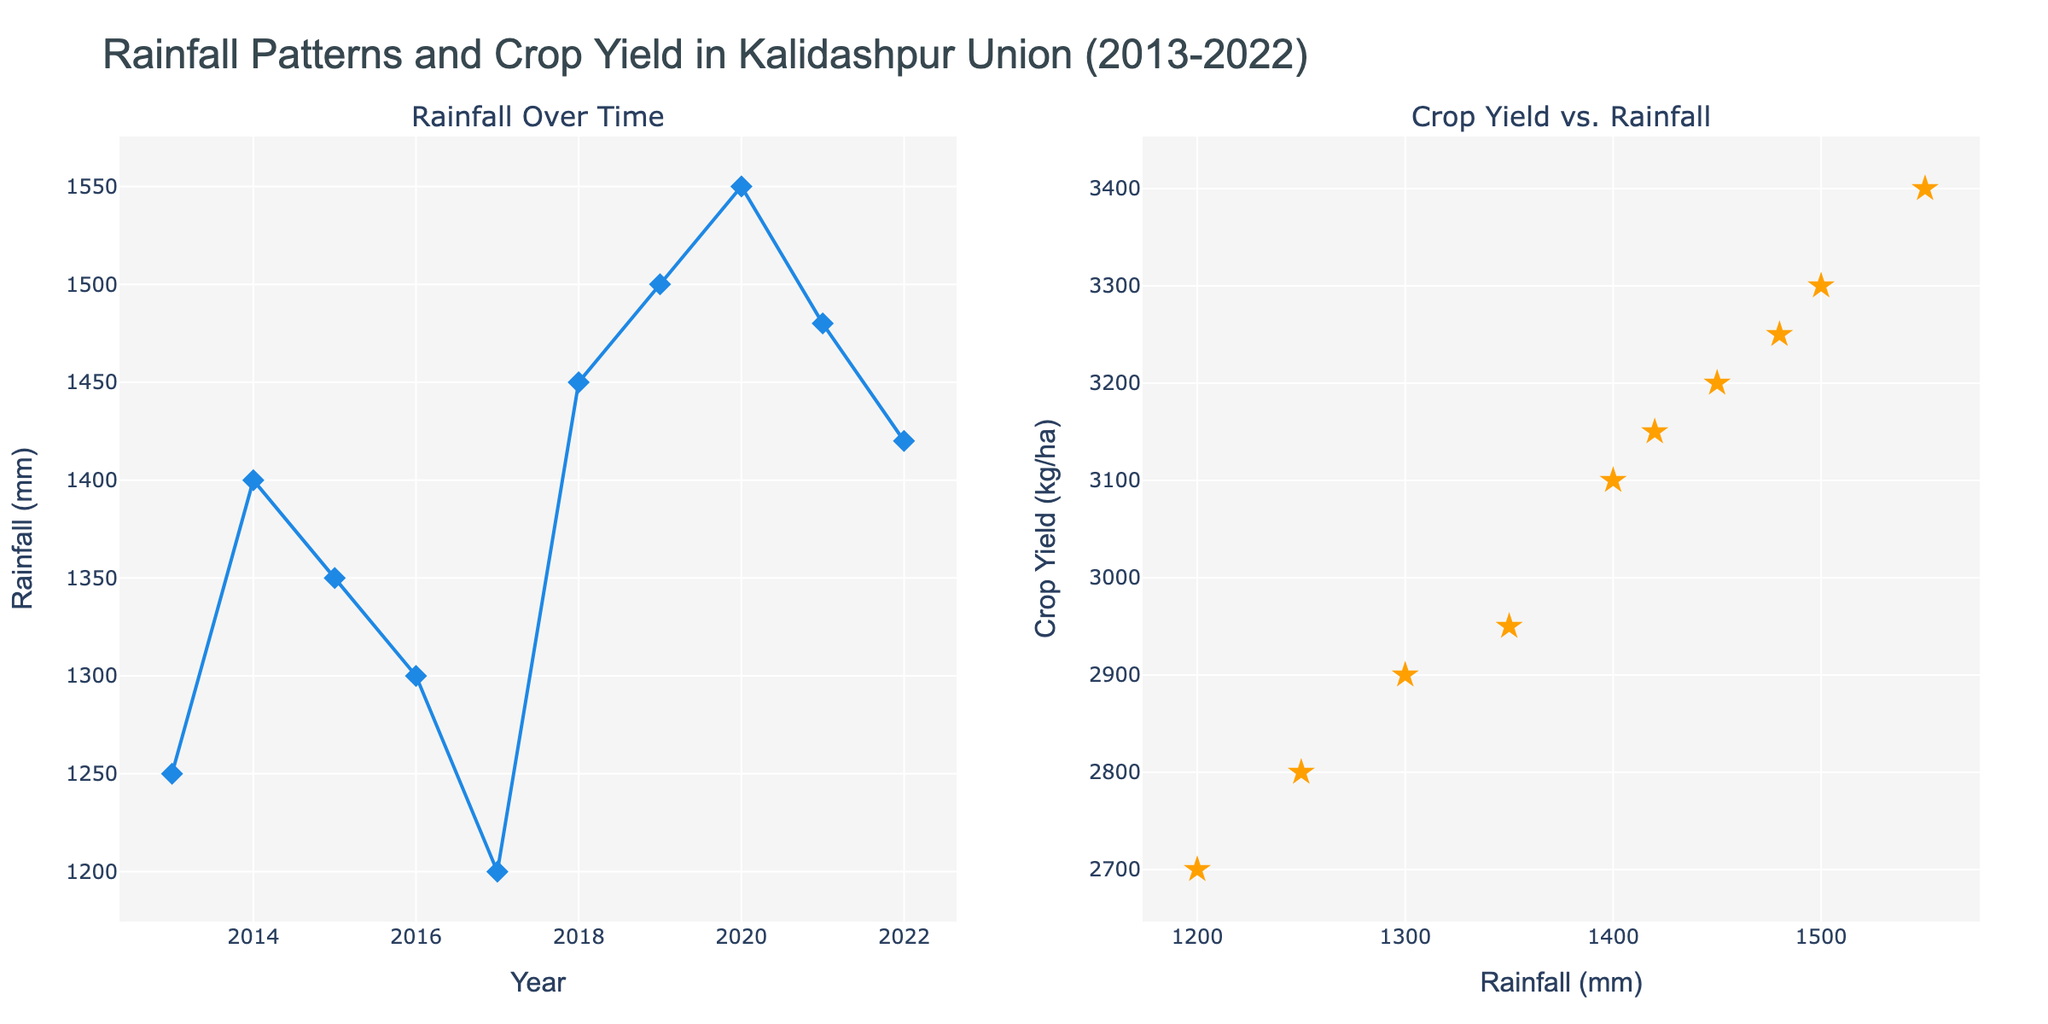What is the title of the figure? The title of the figure is displayed at the top, and it is the main heading for the plots.
Answer: Rainfall Patterns and Crop Yield in Kalidashpur Union (2013-2022) What is the color of the markers representing the crop yield in the scatter plot? The color of the markers for crop yield is indicated in the scatter plot on the right side of the figure.
Answer: Orange How many data points are there in each scatter plot? Both scatter plots represent yearly data from 2013 to 2022. There should be one data point for each year.
Answer: 10 Which year had the highest rainfall, and what was the crop yield that year? The year with the highest rainfall can be identified in the left plot where it peaks, and the corresponding crop yield is found in the right plot.
Answer: 2020, 3400 kg/ha What is the general trend between rainfall and crop yield over the given years? Examine the right scatter plot to observe how increases or decreases in rainfall are generally related to changes in crop yield.
Answer: Positive correlation Which year had the lowest crop yield, and what was the rainfall in that year? Identify the lowest point on the crop yield axis in the right scatter plot and check the corresponding rainfall value on the same plot.
Answer: 2017, 1200 mm Calculate the average rainfall over the past decade. Sum all the rainfall values for each year and divide by the number of years (10).
Answer: (1250 + 1400 + 1350 + 1300 + 1200 + 1450 + 1500 + 1550 + 1480 + 1420) / 10 = 1390 mm How did the rainfall in 2018 compare to the previous year? Find the rainfall values for 2017 and 2018 in the left scatter plot and compare them.
Answer: Increased What is the difference in crop yield between the year with the highest and lowest rainfall? Identify the years with the highest and lowest rainfall, check their crop yields, then compute the difference.
Answer: 3400 kg/ha (2020) - 2700 kg/ha (2017) = 700 kg/ha What pattern, if any, can be seen between years where both rainfall and crop yield increased? Look at both plots to identify years where increases in rainfall are matched with increases in crop yield, noting any consistent patterns.
Answer: Generally positive relationship 